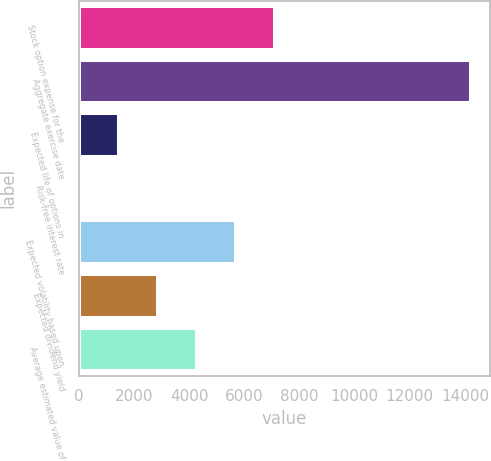Convert chart. <chart><loc_0><loc_0><loc_500><loc_500><bar_chart><fcel>Stock option expense for the<fcel>Aggregate exercise date<fcel>Expected life of options in<fcel>Risk-free interest rate<fcel>Expected volatility based upon<fcel>Expected dividend yield<fcel>Average estimated value of<nl><fcel>7092.9<fcel>14183<fcel>1420.82<fcel>2.8<fcel>5674.88<fcel>2838.84<fcel>4256.86<nl></chart> 